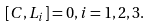Convert formula to latex. <formula><loc_0><loc_0><loc_500><loc_500>[ C , L _ { i } ] = 0 , i = 1 , 2 , 3 .</formula> 